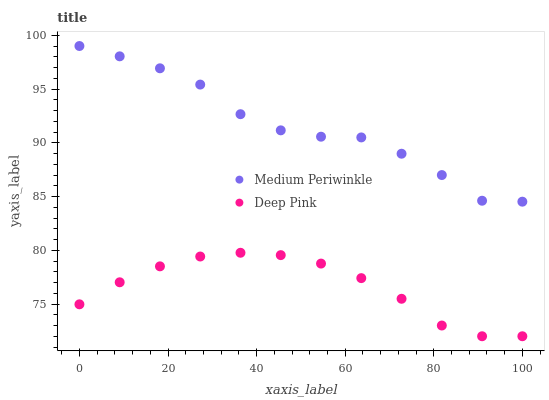Does Deep Pink have the minimum area under the curve?
Answer yes or no. Yes. Does Medium Periwinkle have the maximum area under the curve?
Answer yes or no. Yes. Does Medium Periwinkle have the minimum area under the curve?
Answer yes or no. No. Is Deep Pink the smoothest?
Answer yes or no. Yes. Is Medium Periwinkle the roughest?
Answer yes or no. Yes. Is Medium Periwinkle the smoothest?
Answer yes or no. No. Does Deep Pink have the lowest value?
Answer yes or no. Yes. Does Medium Periwinkle have the lowest value?
Answer yes or no. No. Does Medium Periwinkle have the highest value?
Answer yes or no. Yes. Is Deep Pink less than Medium Periwinkle?
Answer yes or no. Yes. Is Medium Periwinkle greater than Deep Pink?
Answer yes or no. Yes. Does Deep Pink intersect Medium Periwinkle?
Answer yes or no. No. 